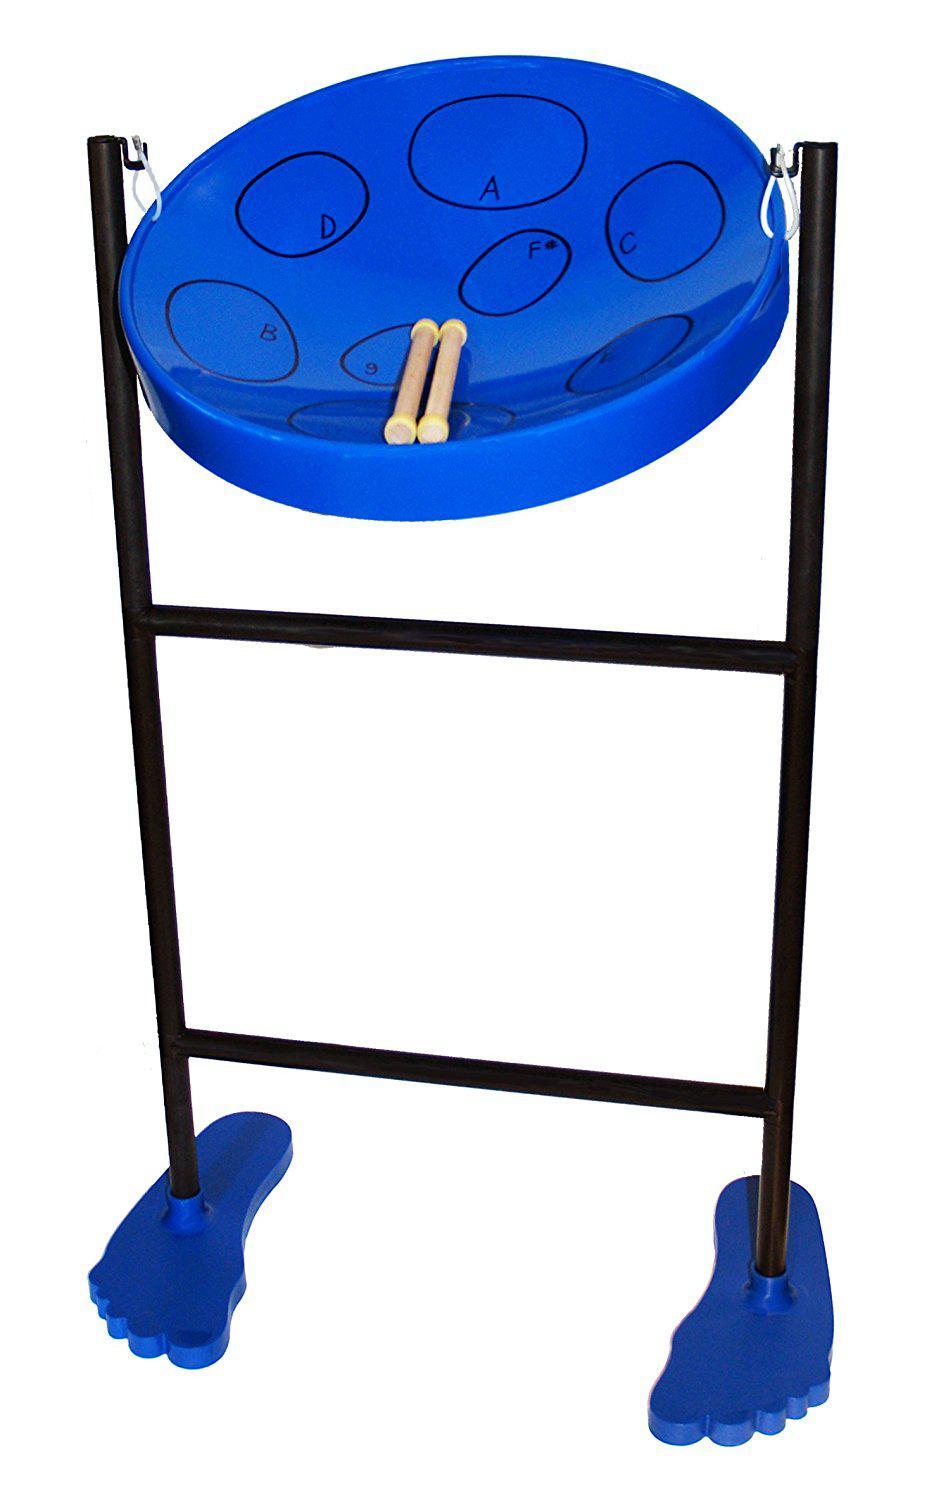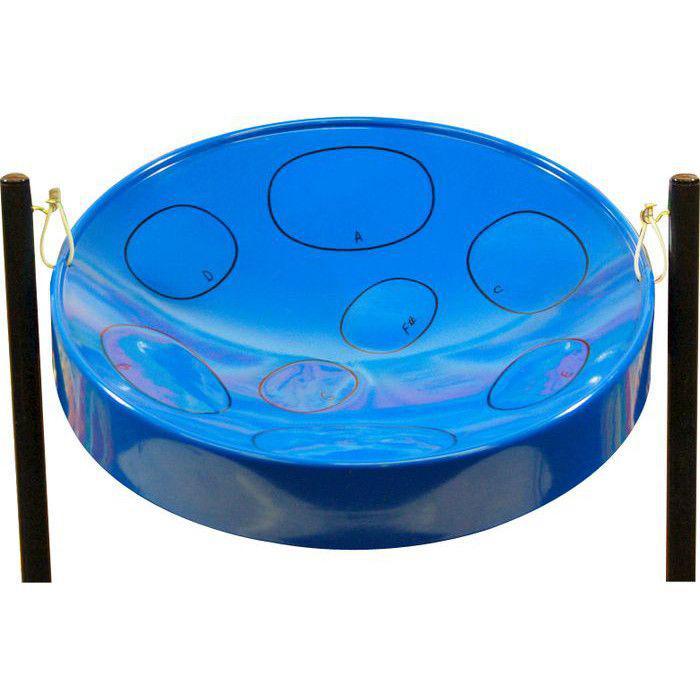The first image is the image on the left, the second image is the image on the right. Assess this claim about the two images: "All the drums are blue.". Correct or not? Answer yes or no. Yes. 